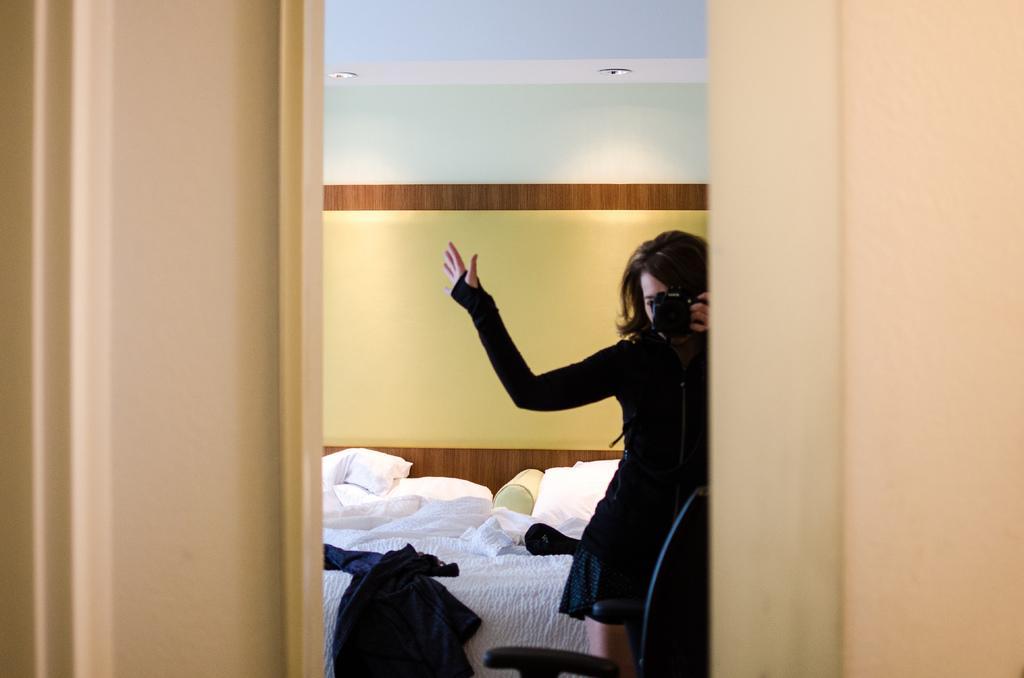How would you summarize this image in a sentence or two? Here in this picture we can see a lady standing. She is wearing a black dress. She is holding a camera in her hand. Beside her there is a bed and pillows on it. And we can see some dresses on that bed. Behind her there is a wall. In front there is a curtain. 